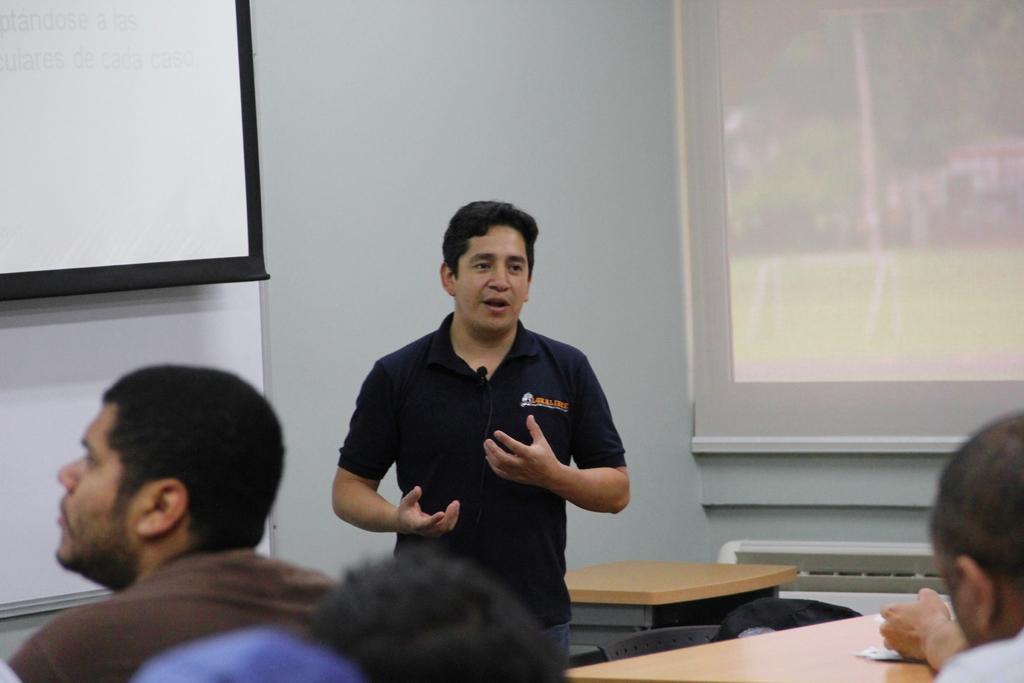Can you describe this image briefly? In this picture there is a man standing and talking and other people sitting in front of him gas tables arrange and their screen behind him and his a window in the background 